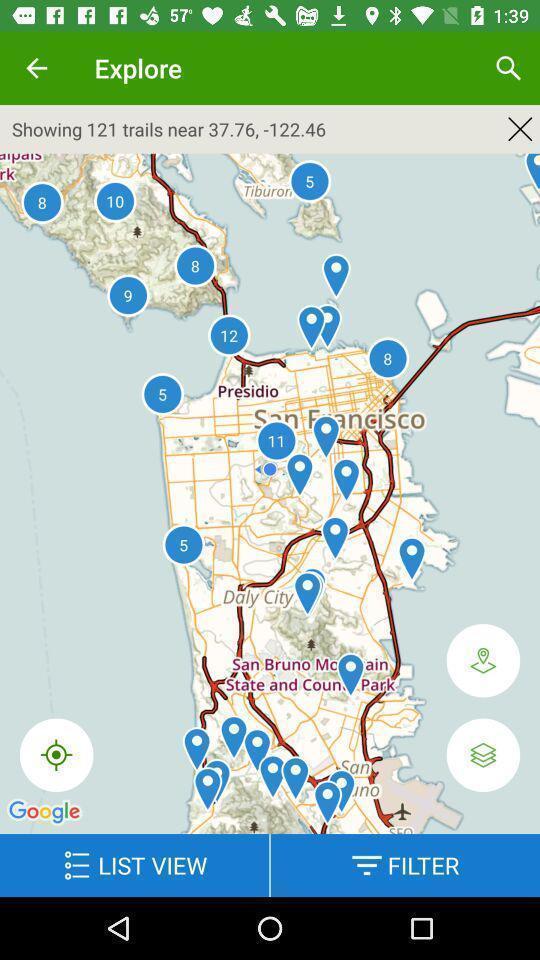Please provide a description for this image. Page displaying map with various options. 